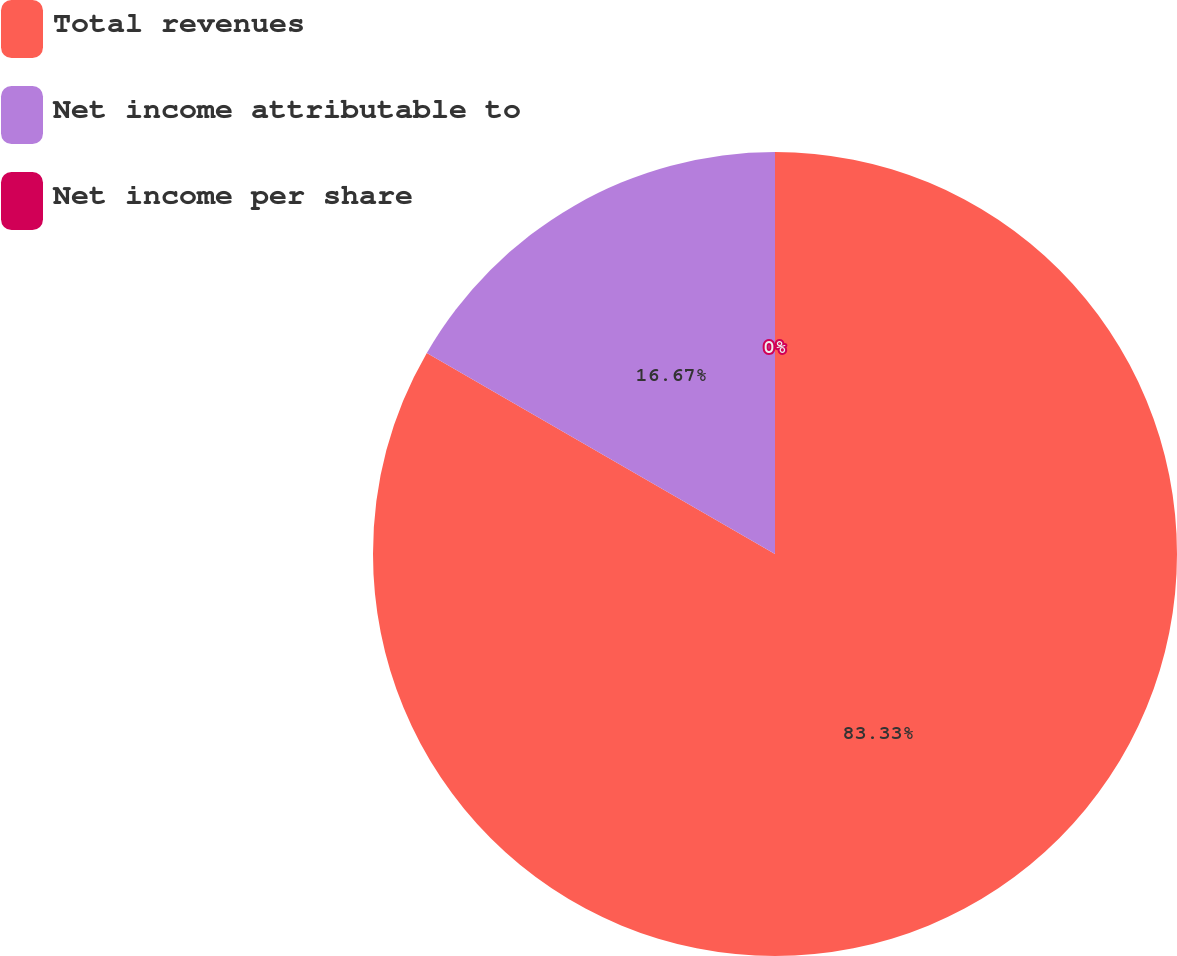Convert chart. <chart><loc_0><loc_0><loc_500><loc_500><pie_chart><fcel>Total revenues<fcel>Net income attributable to<fcel>Net income per share<nl><fcel>83.33%<fcel>16.67%<fcel>0.0%<nl></chart> 